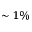Convert formula to latex. <formula><loc_0><loc_0><loc_500><loc_500>\sim 1 \%</formula> 